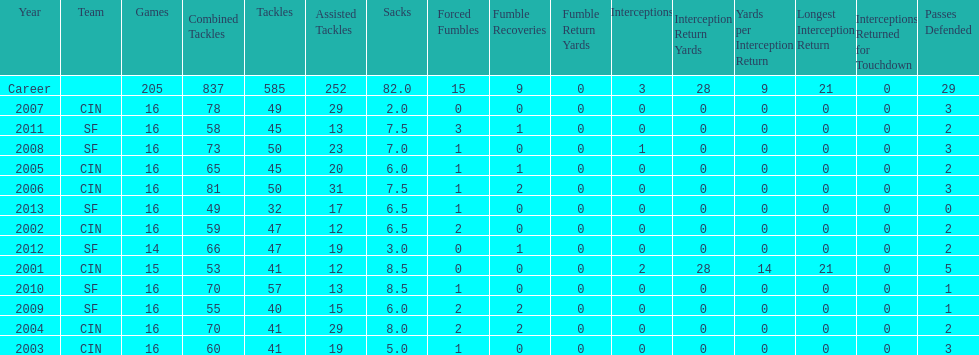How many fumble recoveries did this player have in 2004? 2. 